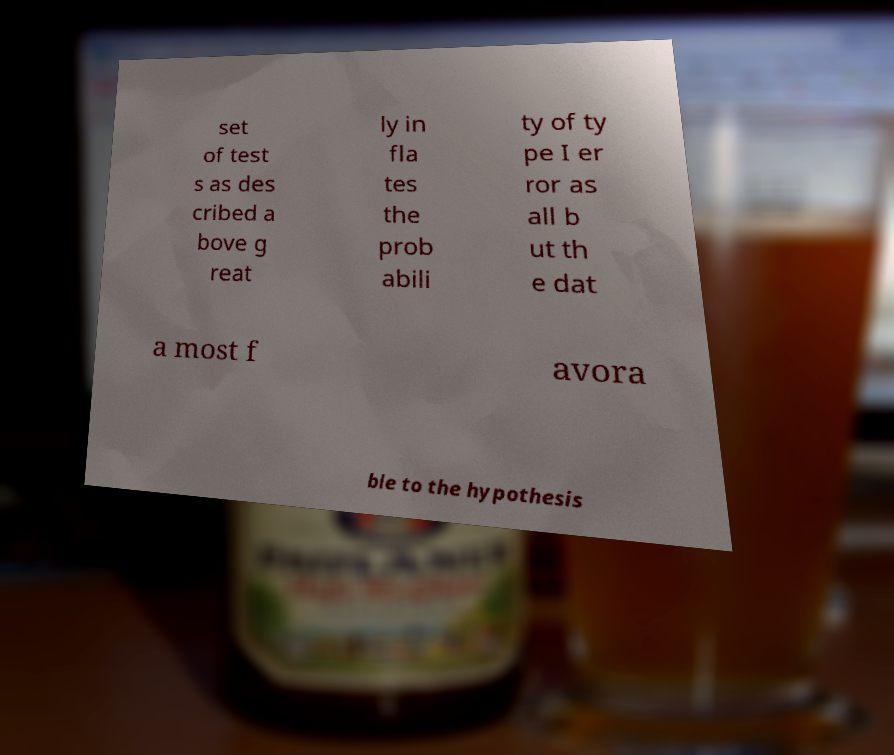What messages or text are displayed in this image? I need them in a readable, typed format. set of test s as des cribed a bove g reat ly in fla tes the prob abili ty of ty pe I er ror as all b ut th e dat a most f avora ble to the hypothesis 